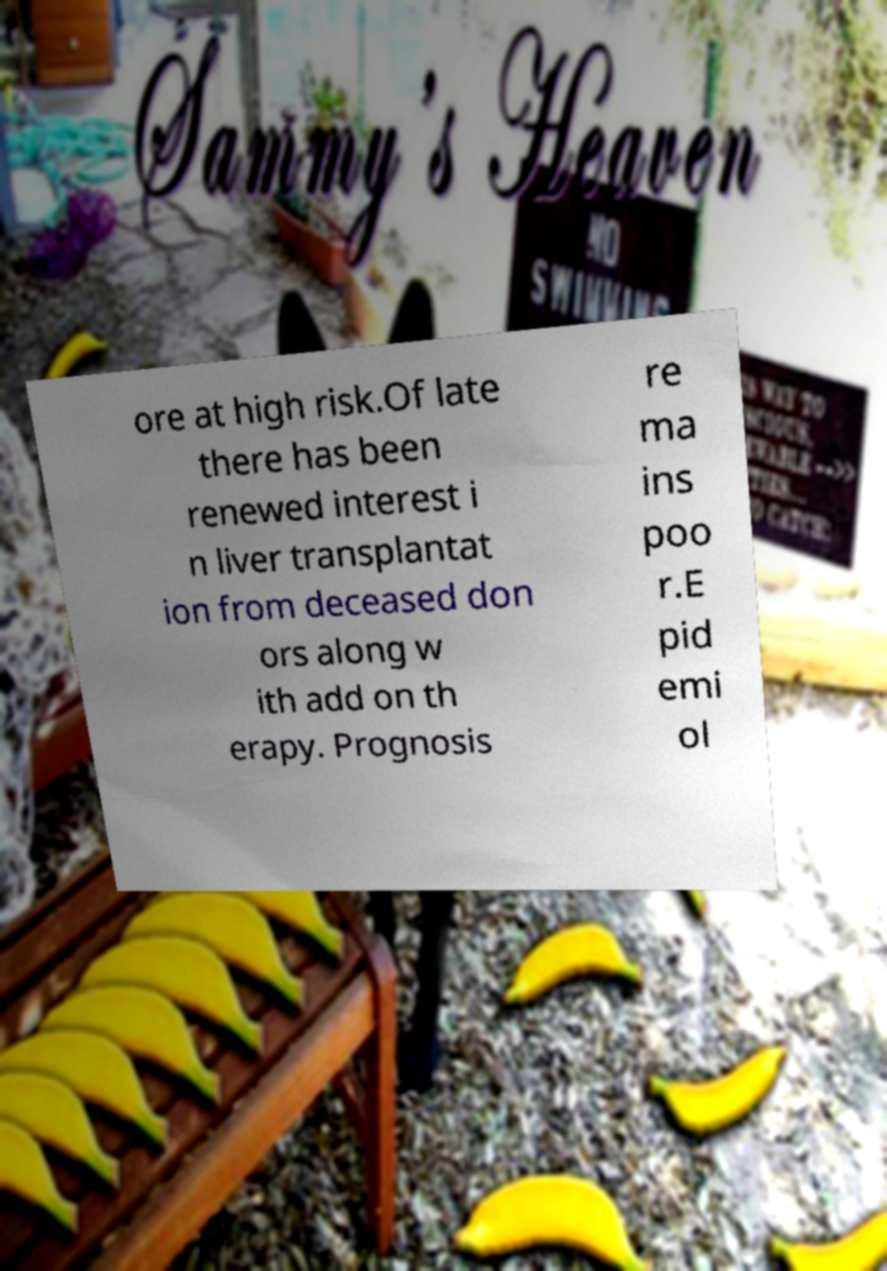Could you assist in decoding the text presented in this image and type it out clearly? ore at high risk.Of late there has been renewed interest i n liver transplantat ion from deceased don ors along w ith add on th erapy. Prognosis re ma ins poo r.E pid emi ol 